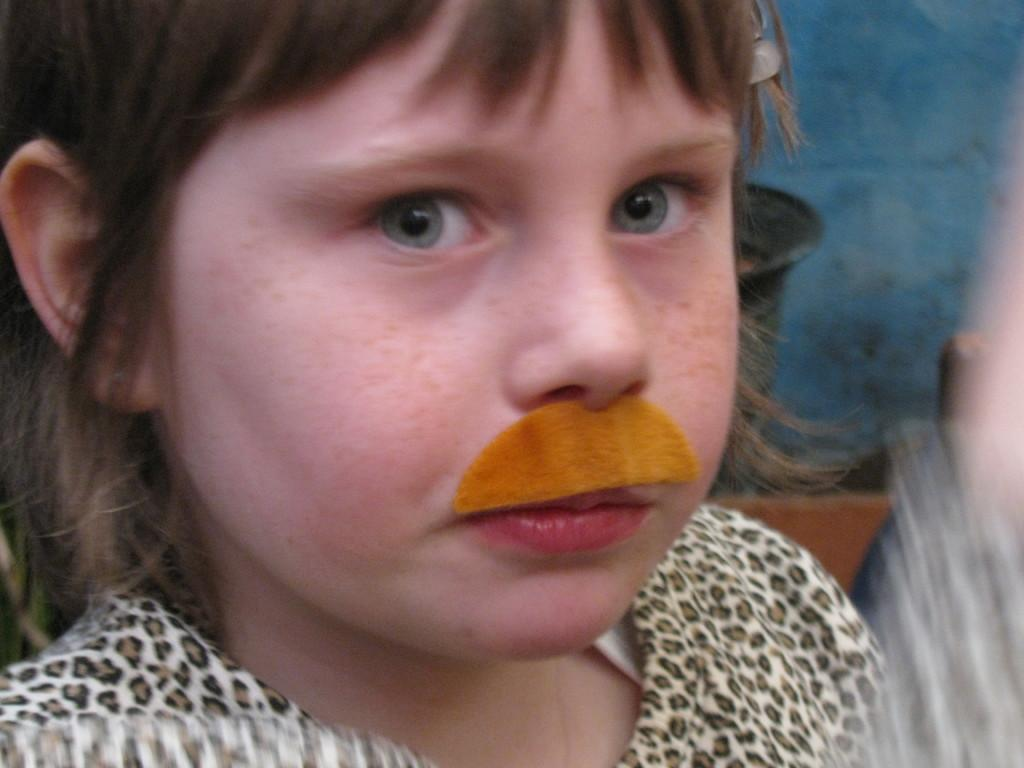What is the main subject of the picture? The main subject of the picture is a child. What is the child doing in the picture? The child is standing in the picture. Which direction is the child looking? The child is looking to the left. What is unique about the child's appearance? The child has an orange mustache. What can be seen in the background of the picture? There is a blue color wall in the background. What type of scarf is the child wearing in the picture? There is no scarf visible in the picture; the child is not wearing one. How many fifths are present in the image? The concept of "fifths" does not apply to the image, as it is a visual representation and not a mathematical equation. 